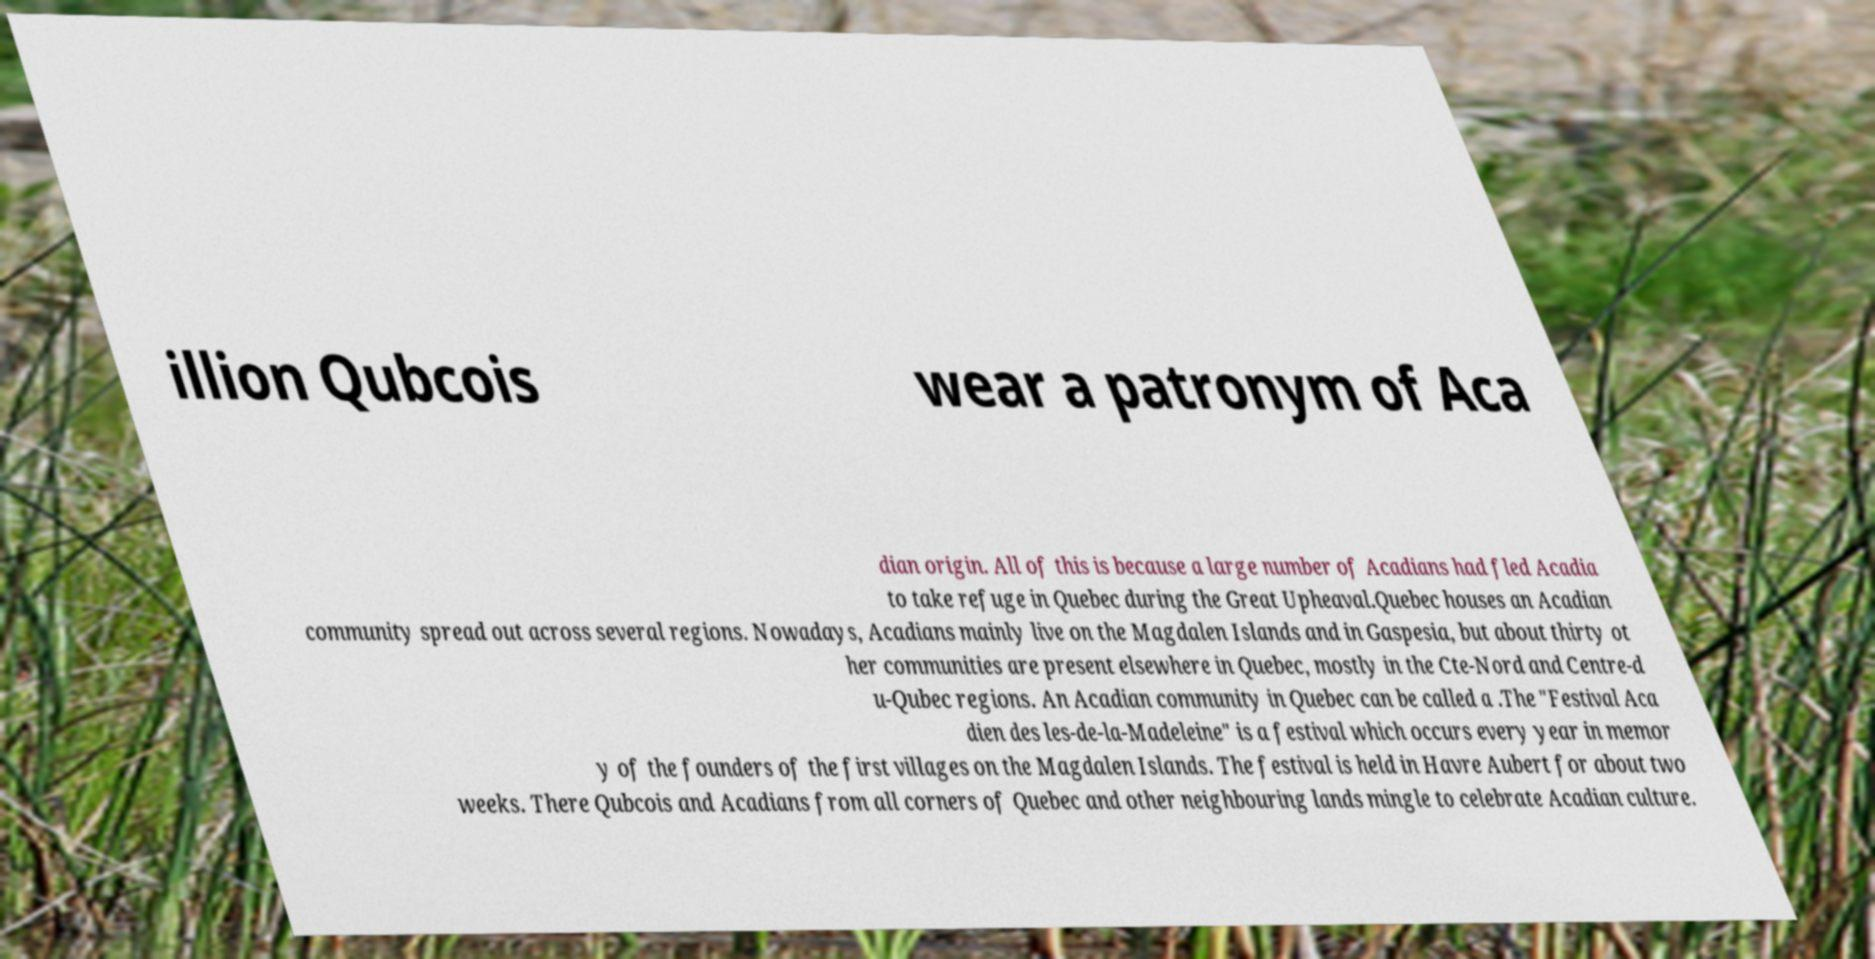Please read and relay the text visible in this image. What does it say? illion Qubcois wear a patronym of Aca dian origin. All of this is because a large number of Acadians had fled Acadia to take refuge in Quebec during the Great Upheaval.Quebec houses an Acadian community spread out across several regions. Nowadays, Acadians mainly live on the Magdalen Islands and in Gaspesia, but about thirty ot her communities are present elsewhere in Quebec, mostly in the Cte-Nord and Centre-d u-Qubec regions. An Acadian community in Quebec can be called a .The "Festival Aca dien des les-de-la-Madeleine" is a festival which occurs every year in memor y of the founders of the first villages on the Magdalen Islands. The festival is held in Havre Aubert for about two weeks. There Qubcois and Acadians from all corners of Quebec and other neighbouring lands mingle to celebrate Acadian culture. 